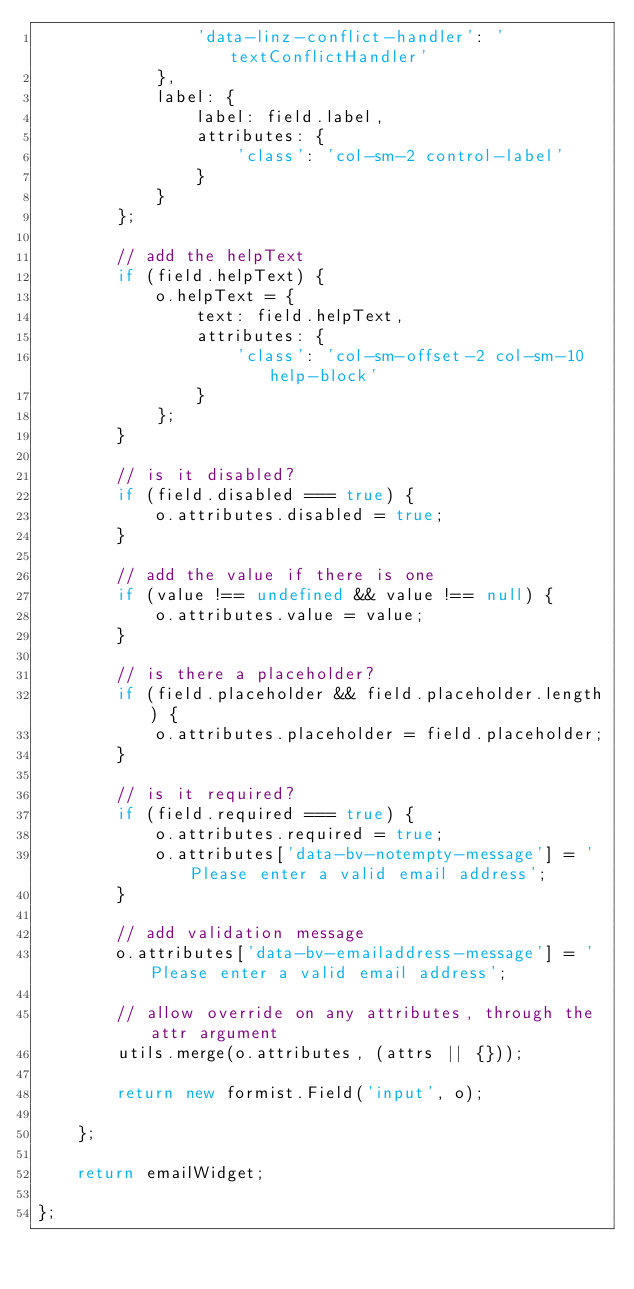Convert code to text. <code><loc_0><loc_0><loc_500><loc_500><_JavaScript_>                'data-linz-conflict-handler': 'textConflictHandler'
            },
            label: {
                label: field.label,
                attributes: {
                    'class': 'col-sm-2 control-label'
                }
            }
        };

        // add the helpText
        if (field.helpText) {
            o.helpText = {
                text: field.helpText,
                attributes: {
                    'class': 'col-sm-offset-2 col-sm-10 help-block'
                }
            };
        }

        // is it disabled?
        if (field.disabled === true) {
            o.attributes.disabled = true;
        }

        // add the value if there is one
        if (value !== undefined && value !== null) {
            o.attributes.value = value;
        }

        // is there a placeholder?
        if (field.placeholder && field.placeholder.length) {
            o.attributes.placeholder = field.placeholder;
        }

        // is it required?
        if (field.required === true) {
            o.attributes.required = true;
            o.attributes['data-bv-notempty-message'] = 'Please enter a valid email address';
        }

        // add validation message
        o.attributes['data-bv-emailaddress-message'] = 'Please enter a valid email address';

        // allow override on any attributes, through the attr argument
        utils.merge(o.attributes, (attrs || {}));

        return new formist.Field('input', o);

    };

    return emailWidget;

};
</code> 